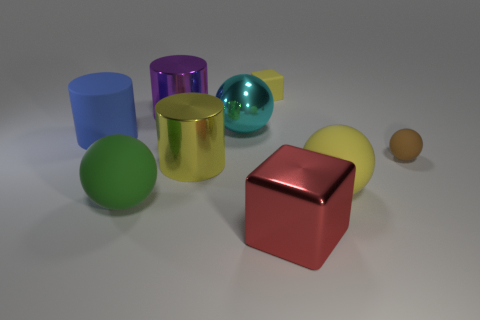Subtract all green blocks. Subtract all blue cylinders. How many blocks are left? 2 Add 1 yellow blocks. How many objects exist? 10 Subtract all cubes. How many objects are left? 7 Add 3 big matte balls. How many big matte balls exist? 5 Subtract 1 cyan balls. How many objects are left? 8 Subtract all small brown rubber cubes. Subtract all brown rubber things. How many objects are left? 8 Add 6 large green things. How many large green things are left? 7 